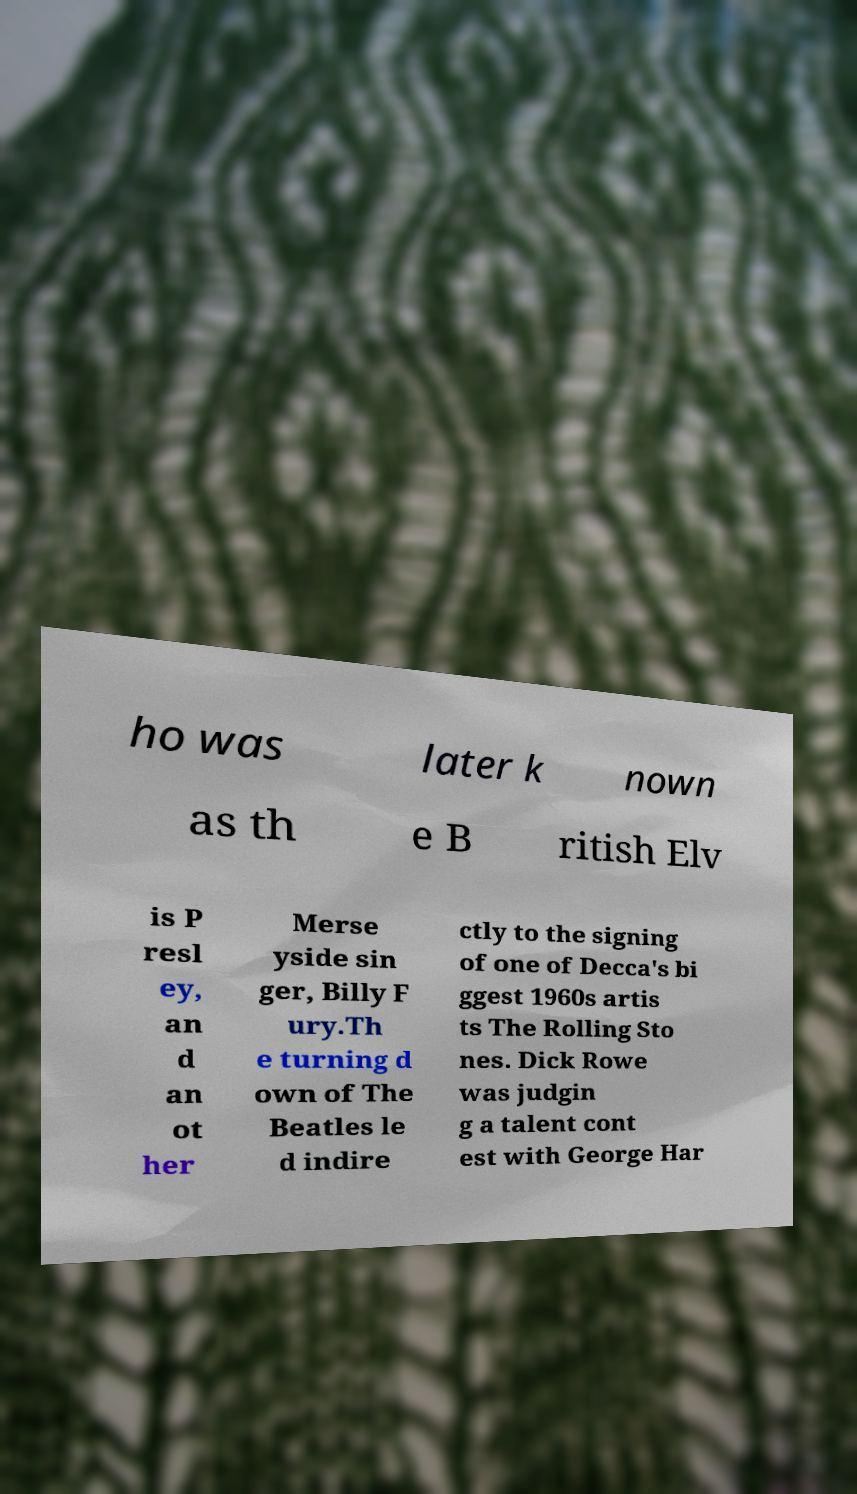Could you extract and type out the text from this image? ho was later k nown as th e B ritish Elv is P resl ey, an d an ot her Merse yside sin ger, Billy F ury.Th e turning d own of The Beatles le d indire ctly to the signing of one of Decca's bi ggest 1960s artis ts The Rolling Sto nes. Dick Rowe was judgin g a talent cont est with George Har 